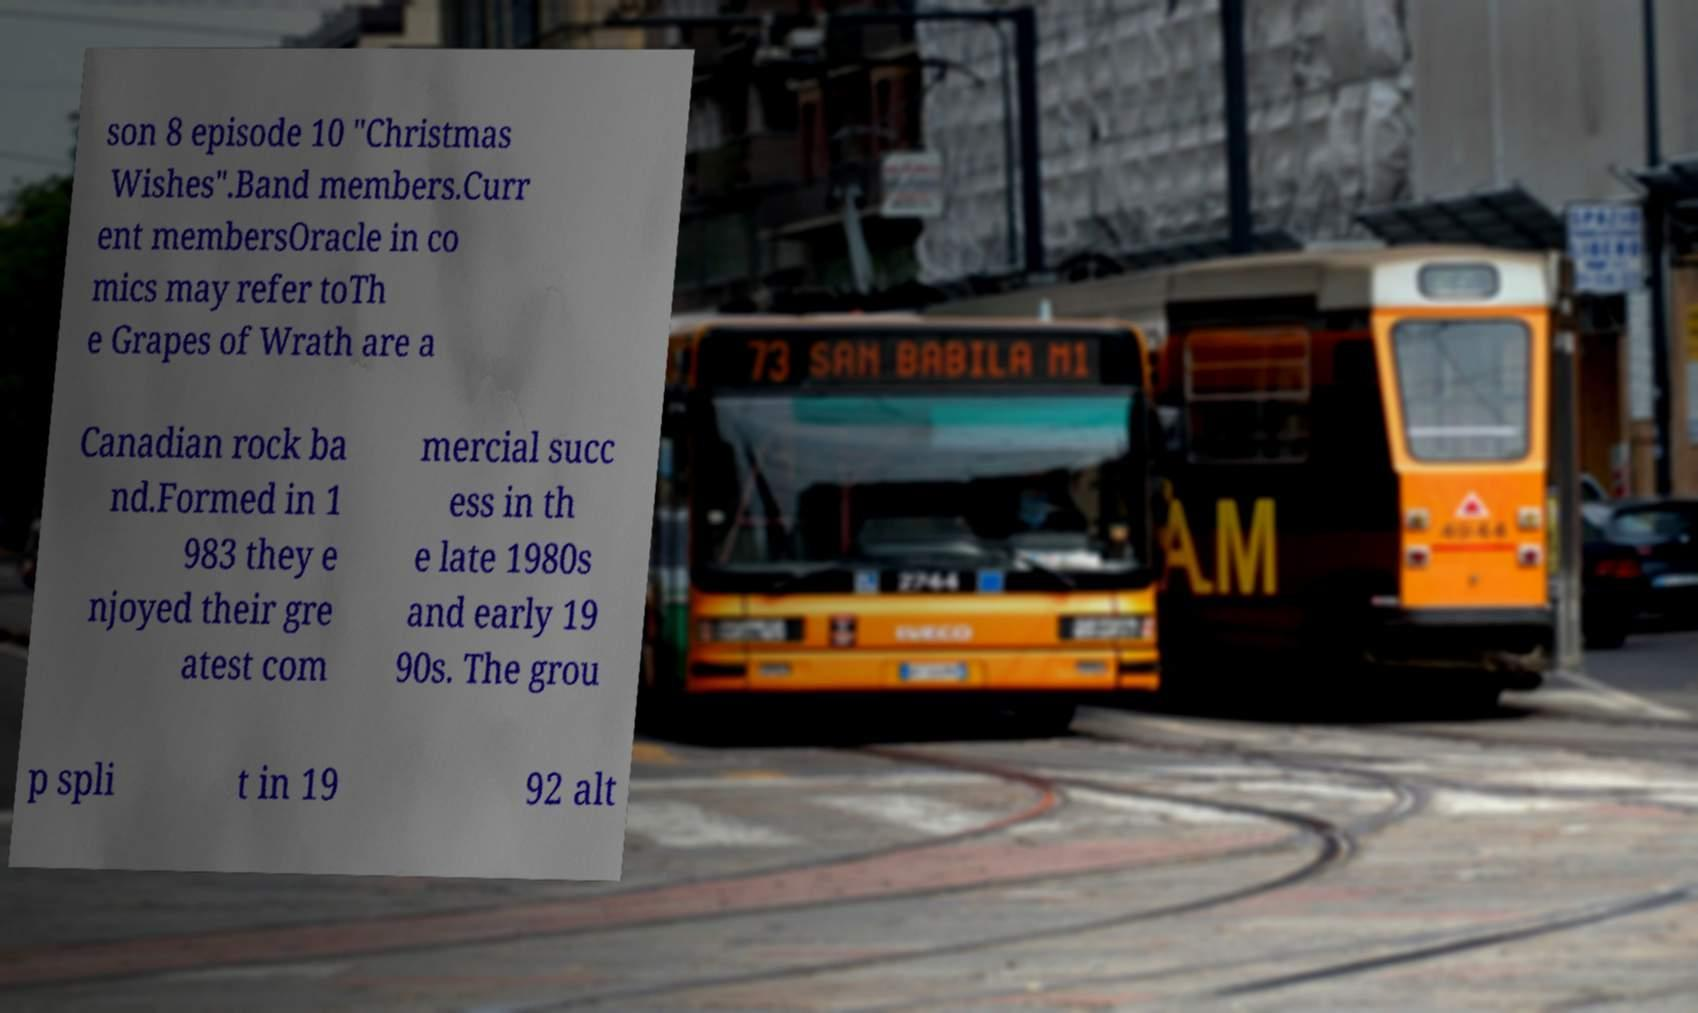There's text embedded in this image that I need extracted. Can you transcribe it verbatim? son 8 episode 10 "Christmas Wishes".Band members.Curr ent membersOracle in co mics may refer toTh e Grapes of Wrath are a Canadian rock ba nd.Formed in 1 983 they e njoyed their gre atest com mercial succ ess in th e late 1980s and early 19 90s. The grou p spli t in 19 92 alt 